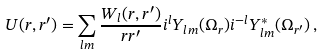<formula> <loc_0><loc_0><loc_500><loc_500>U ( { r } , { r ^ { \prime } } ) = \sum _ { l m } \frac { W _ { l } ( r , r ^ { \prime } ) } { r r ^ { \prime } } i ^ { l } Y _ { l m } ( \Omega _ { r } ) i ^ { - l } Y ^ { \ast } _ { l m } ( \Omega _ { r ^ { \prime } } ) \, ,</formula> 